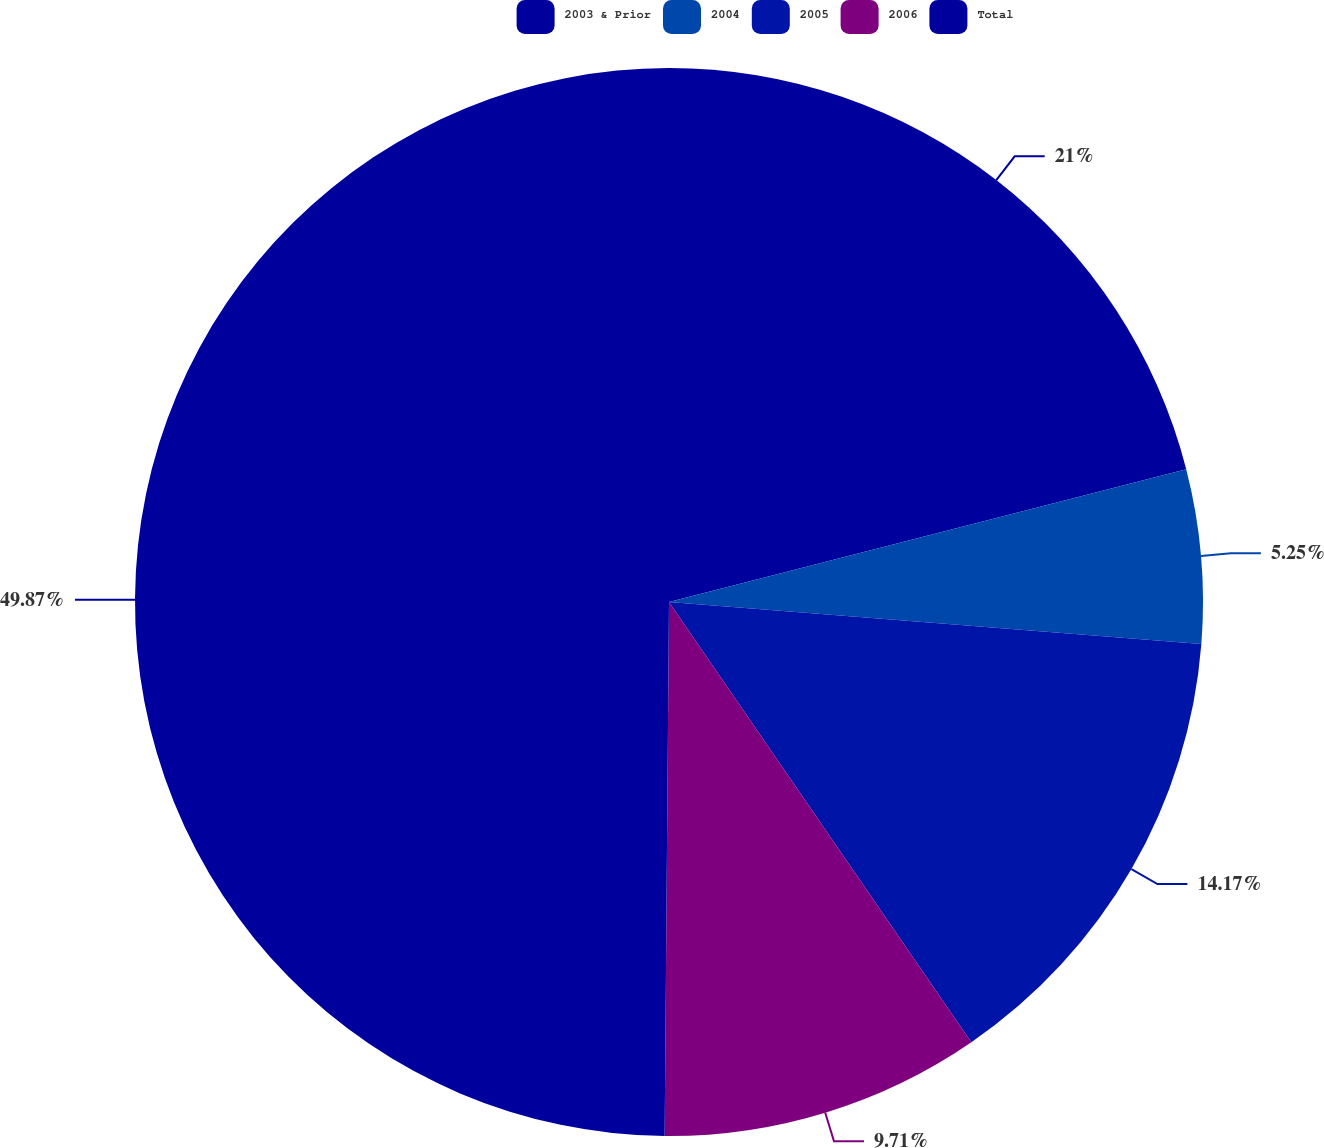Convert chart. <chart><loc_0><loc_0><loc_500><loc_500><pie_chart><fcel>2003 & Prior<fcel>2004<fcel>2005<fcel>2006<fcel>Total<nl><fcel>21.0%<fcel>5.25%<fcel>14.17%<fcel>9.71%<fcel>49.87%<nl></chart> 